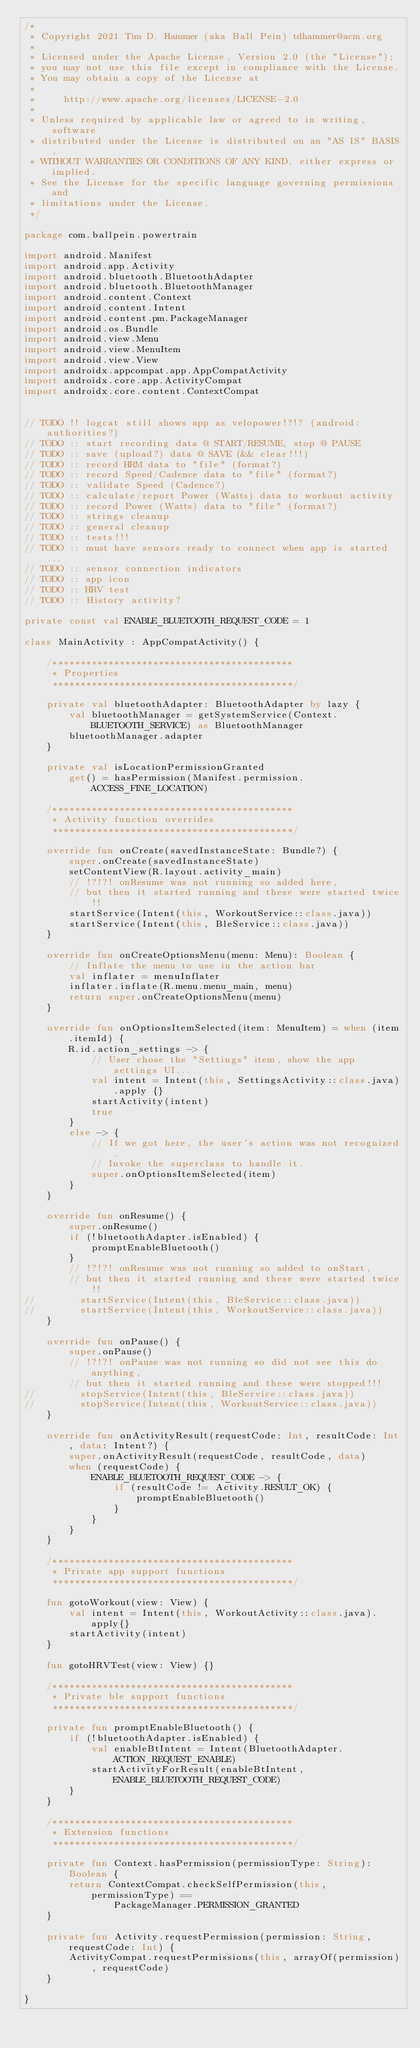Convert code to text. <code><loc_0><loc_0><loc_500><loc_500><_Kotlin_>/*
 * Copyright 2021 Tim D. Hammer (aka Ball Pein) tdhammer@acm.org
 *
 * Licensed under the Apache License, Version 2.0 (the "License");
 * you may not use this file except in compliance with the License.
 * You may obtain a copy of the License at
 *
 *     http://www.apache.org/licenses/LICENSE-2.0
 *
 * Unless required by applicable law or agreed to in writing, software
 * distributed under the License is distributed on an "AS IS" BASIS,
 * WITHOUT WARRANTIES OR CONDITIONS OF ANY KIND, either express or implied.
 * See the License for the specific language governing permissions and
 * limitations under the License.
 */

package com.ballpein.powertrain

import android.Manifest
import android.app.Activity
import android.bluetooth.BluetoothAdapter
import android.bluetooth.BluetoothManager
import android.content.Context
import android.content.Intent
import android.content.pm.PackageManager
import android.os.Bundle
import android.view.Menu
import android.view.MenuItem
import android.view.View
import androidx.appcompat.app.AppCompatActivity
import androidx.core.app.ActivityCompat
import androidx.core.content.ContextCompat


// TODO !! logcat still shows app as velopower!?!? (android:authorities?)
// TODO :: start recording data @ START/RESUME, stop @ PAUSE
// TODO :: save (upload?) data @ SAVE (&& clear!!!)
// TODO :: record HRM data to "file" (format?)
// TODO :: record Speed/Cadence data to "file" (format?)
// TODO :: validate Speed (Cadence?)
// TODO :: calculate/report Power (Watts) data to workout activity
// TODO :: record Power (Watts) data to "file" (format?)
// TODO :: strings cleanup
// TODO :: general cleanup
// TODO :: tests!!!
// TODO :: must have sensors ready to connect when app is started...
// TODO :: sensor connection indicators
// TODO :: app icon
// TODO :: HRV test
// TODO :: History activity?

private const val ENABLE_BLUETOOTH_REQUEST_CODE = 1

class MainActivity : AppCompatActivity() {

    /*******************************************
     * Properties
     *******************************************/

    private val bluetoothAdapter: BluetoothAdapter by lazy {
        val bluetoothManager = getSystemService(Context.BLUETOOTH_SERVICE) as BluetoothManager
        bluetoothManager.adapter
    }

    private val isLocationPermissionGranted
        get() = hasPermission(Manifest.permission.ACCESS_FINE_LOCATION)

    /*******************************************
     * Activity function overrides
     *******************************************/

    override fun onCreate(savedInstanceState: Bundle?) {
        super.onCreate(savedInstanceState)
        setContentView(R.layout.activity_main)
        // !?!?! onResume was not running so added here,
        // but then it started running and these were started twice!!
        startService(Intent(this, WorkoutService::class.java))
        startService(Intent(this, BleService::class.java))
    }

    override fun onCreateOptionsMenu(menu: Menu): Boolean {
        // Inflate the menu to use in the action bar
        val inflater = menuInflater
        inflater.inflate(R.menu.menu_main, menu)
        return super.onCreateOptionsMenu(menu)
    }

    override fun onOptionsItemSelected(item: MenuItem) = when (item.itemId) {
        R.id.action_settings -> {
            // User chose the "Settings" item, show the app settings UI...
            val intent = Intent(this, SettingsActivity::class.java).apply {}
            startActivity(intent)
            true
        }
        else -> {
            // If we got here, the user's action was not recognized.
            // Invoke the superclass to handle it.
            super.onOptionsItemSelected(item)
        }
    }

    override fun onResume() {
        super.onResume()
        if (!bluetoothAdapter.isEnabled) {
            promptEnableBluetooth()
        }
        // !?!?! onResume was not running so added to onStart,
        // but then it started running and these were started twice!!
//        startService(Intent(this, BleService::class.java))
//        startService(Intent(this, WorkoutService::class.java))
    }

    override fun onPause() {
        super.onPause()
        // !?!?! onPause was not running so did not see this do anything,
        // but then it started running and these were stopped!!!
//        stopService(Intent(this, BleService::class.java))
//        stopService(Intent(this, WorkoutService::class.java))
    }

    override fun onActivityResult(requestCode: Int, resultCode: Int, data: Intent?) {
        super.onActivityResult(requestCode, resultCode, data)
        when (requestCode) {
            ENABLE_BLUETOOTH_REQUEST_CODE -> {
                if (resultCode != Activity.RESULT_OK) {
                    promptEnableBluetooth()
                }
            }
        }
    }

    /*******************************************
     * Private app support functions
     *******************************************/

    fun gotoWorkout(view: View) {
        val intent = Intent(this, WorkoutActivity::class.java).apply{}
        startActivity(intent)
    }

    fun gotoHRVTest(view: View) {}

    /*******************************************
     * Private ble support functions
     *******************************************/

    private fun promptEnableBluetooth() {
        if (!bluetoothAdapter.isEnabled) {
            val enableBtIntent = Intent(BluetoothAdapter.ACTION_REQUEST_ENABLE)
            startActivityForResult(enableBtIntent, ENABLE_BLUETOOTH_REQUEST_CODE)
        }
    }

    /*******************************************
     * Extension functions
     *******************************************/

    private fun Context.hasPermission(permissionType: String): Boolean {
        return ContextCompat.checkSelfPermission(this, permissionType) ==
                PackageManager.PERMISSION_GRANTED
    }

    private fun Activity.requestPermission(permission: String, requestCode: Int) {
        ActivityCompat.requestPermissions(this, arrayOf(permission), requestCode)
    }

}</code> 